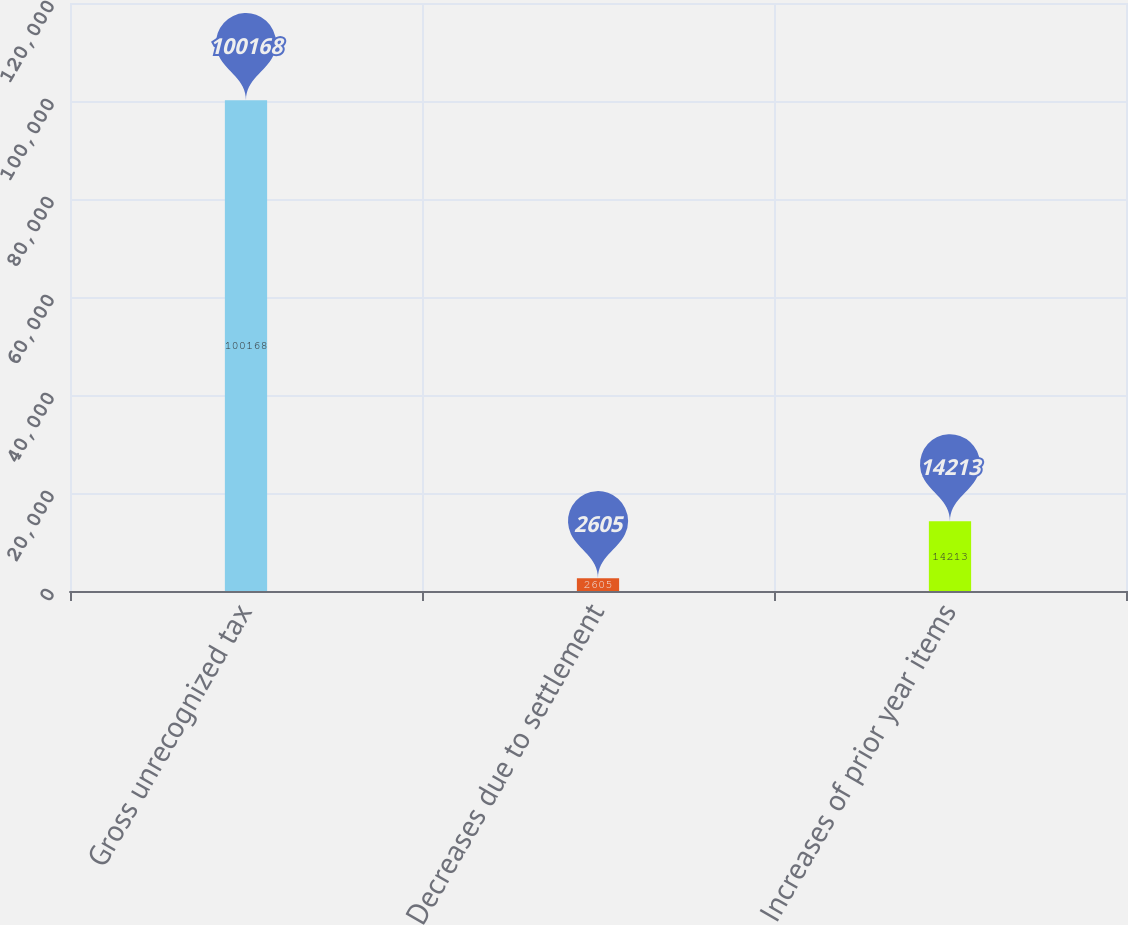<chart> <loc_0><loc_0><loc_500><loc_500><bar_chart><fcel>Gross unrecognized tax<fcel>Decreases due to settlement<fcel>Increases of prior year items<nl><fcel>100168<fcel>2605<fcel>14213<nl></chart> 